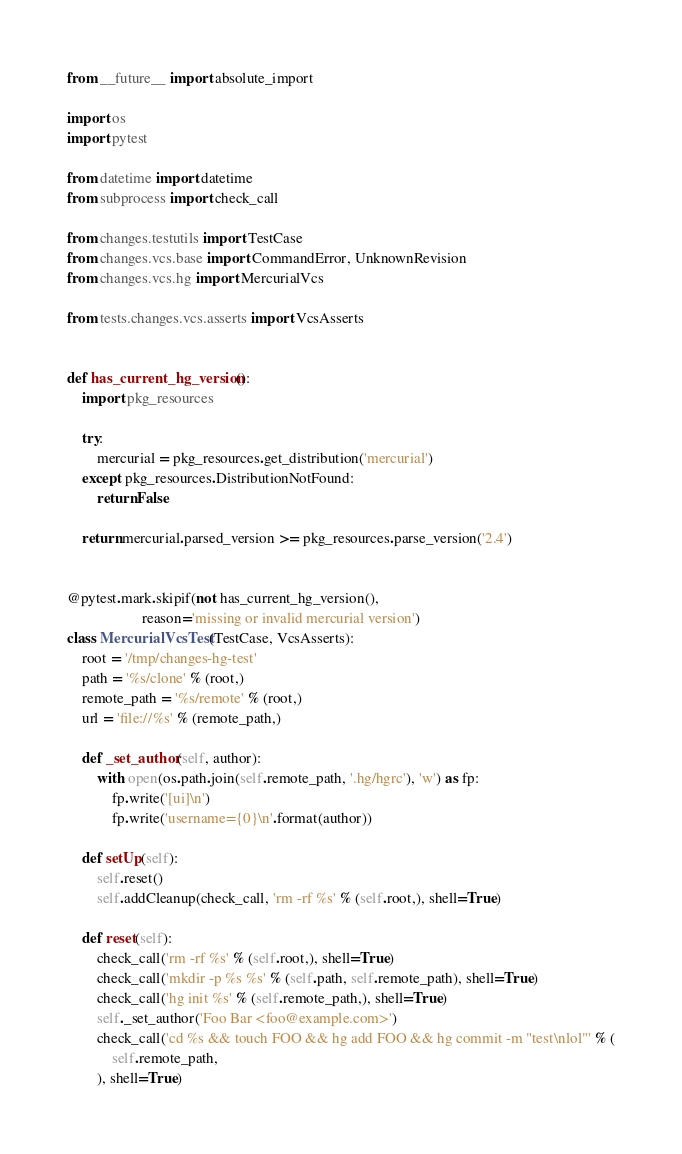<code> <loc_0><loc_0><loc_500><loc_500><_Python_>from __future__ import absolute_import

import os
import pytest

from datetime import datetime
from subprocess import check_call

from changes.testutils import TestCase
from changes.vcs.base import CommandError, UnknownRevision
from changes.vcs.hg import MercurialVcs

from tests.changes.vcs.asserts import VcsAsserts


def has_current_hg_version():
    import pkg_resources

    try:
        mercurial = pkg_resources.get_distribution('mercurial')
    except pkg_resources.DistributionNotFound:
        return False

    return mercurial.parsed_version >= pkg_resources.parse_version('2.4')


@pytest.mark.skipif(not has_current_hg_version(),
                    reason='missing or invalid mercurial version')
class MercurialVcsTest(TestCase, VcsAsserts):
    root = '/tmp/changes-hg-test'
    path = '%s/clone' % (root,)
    remote_path = '%s/remote' % (root,)
    url = 'file://%s' % (remote_path,)

    def _set_author(self, author):
        with open(os.path.join(self.remote_path, '.hg/hgrc'), 'w') as fp:
            fp.write('[ui]\n')
            fp.write('username={0}\n'.format(author))

    def setUp(self):
        self.reset()
        self.addCleanup(check_call, 'rm -rf %s' % (self.root,), shell=True)

    def reset(self):
        check_call('rm -rf %s' % (self.root,), shell=True)
        check_call('mkdir -p %s %s' % (self.path, self.remote_path), shell=True)
        check_call('hg init %s' % (self.remote_path,), shell=True)
        self._set_author('Foo Bar <foo@example.com>')
        check_call('cd %s && touch FOO && hg add FOO && hg commit -m "test\nlol"' % (
            self.remote_path,
        ), shell=True)</code> 